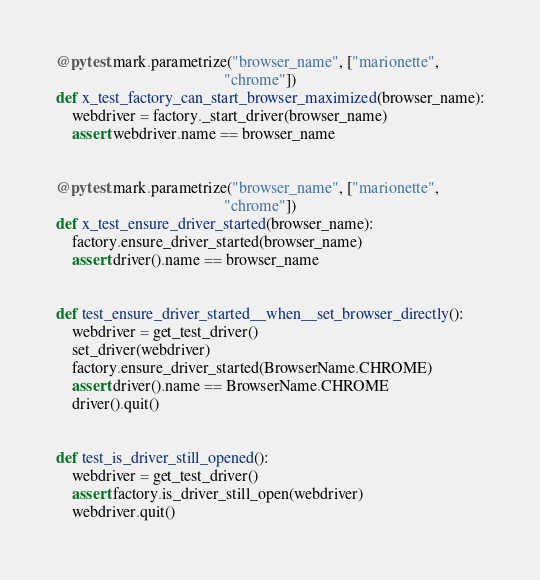Convert code to text. <code><loc_0><loc_0><loc_500><loc_500><_Python_>

@pytest.mark.parametrize("browser_name", ["marionette",
                                          "chrome"])
def x_test_factory_can_start_browser_maximized(browser_name):
    webdriver = factory._start_driver(browser_name)
    assert webdriver.name == browser_name


@pytest.mark.parametrize("browser_name", ["marionette",
                                          "chrome"])
def x_test_ensure_driver_started(browser_name):
    factory.ensure_driver_started(browser_name)
    assert driver().name == browser_name


def test_ensure_driver_started__when__set_browser_directly():
    webdriver = get_test_driver()
    set_driver(webdriver)
    factory.ensure_driver_started(BrowserName.CHROME)
    assert driver().name == BrowserName.CHROME
    driver().quit()


def test_is_driver_still_opened():
    webdriver = get_test_driver()
    assert factory.is_driver_still_open(webdriver)
    webdriver.quit()</code> 